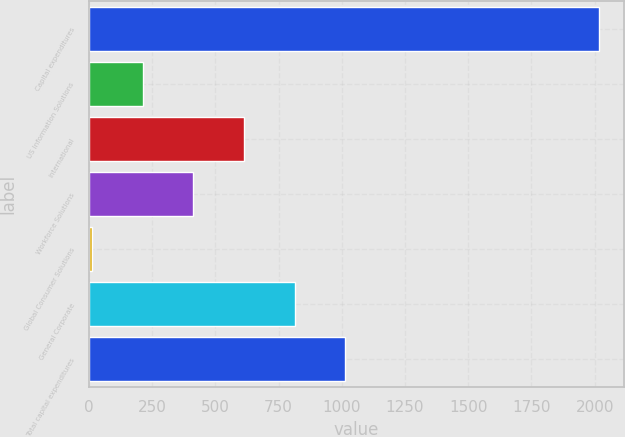Convert chart to OTSL. <chart><loc_0><loc_0><loc_500><loc_500><bar_chart><fcel>Capital expenditures<fcel>US Information Solutions<fcel>International<fcel>Workforce Solutions<fcel>Global Consumer Solutions<fcel>General Corporate<fcel>Total capital expenditures<nl><fcel>2016<fcel>212.67<fcel>613.41<fcel>413.04<fcel>12.3<fcel>813.78<fcel>1014.15<nl></chart> 